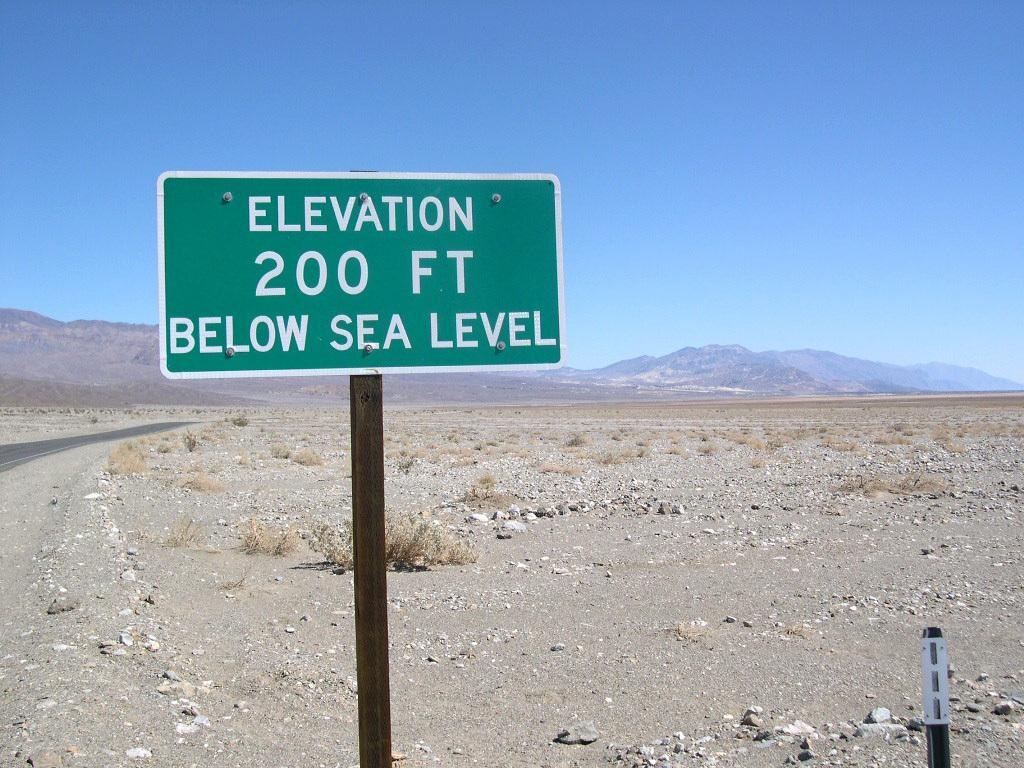<image>
Render a clear and concise summary of the photo. an elevation sign that is outside in day 